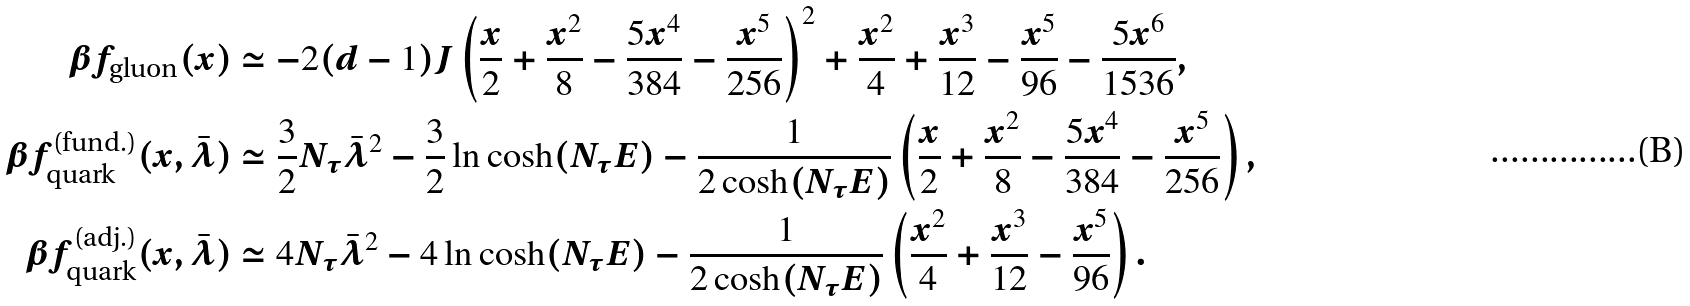Convert formula to latex. <formula><loc_0><loc_0><loc_500><loc_500>\beta f _ { \text {gluon} } ( x ) & \simeq - 2 ( d - 1 ) J \left ( \frac { x } { 2 } + \frac { x ^ { 2 } } { 8 } - \frac { 5 x ^ { 4 } } { 3 8 4 } - \frac { x ^ { 5 } } { 2 5 6 } \right ) ^ { 2 } + \frac { x ^ { 2 } } { 4 } + \frac { x ^ { 3 } } { 1 2 } - \frac { x ^ { 5 } } { 9 6 } - \frac { 5 x ^ { 6 } } { 1 5 3 6 } , \\ \beta f _ { \text {quark} } ^ { \text {(fund.)} } ( x , \bar { \lambda } ) & \simeq \frac { 3 } { 2 } N _ { \tau } \bar { \lambda } ^ { 2 } - \frac { 3 } { 2 } \ln \cosh ( N _ { \tau } E ) - \frac { 1 } { 2 \cosh ( N _ { \tau } E ) } \left ( \frac { x } { 2 } + \frac { x ^ { 2 } } { 8 } - \frac { 5 x ^ { 4 } } { 3 8 4 } - \frac { x ^ { 5 } } { 2 5 6 } \right ) , \\ \beta f _ { \text {quark} } ^ { \text {(adj.)} } ( x , \bar { \lambda } ) & \simeq 4 N _ { \tau } \bar { \lambda } ^ { 2 } - 4 \ln \cosh ( N _ { \tau } E ) - \frac { 1 } { 2 \cosh ( N _ { \tau } E ) } \left ( \frac { x ^ { 2 } } { 4 } + \frac { x ^ { 3 } } { 1 2 } - \frac { x ^ { 5 } } { 9 6 } \right ) .</formula> 